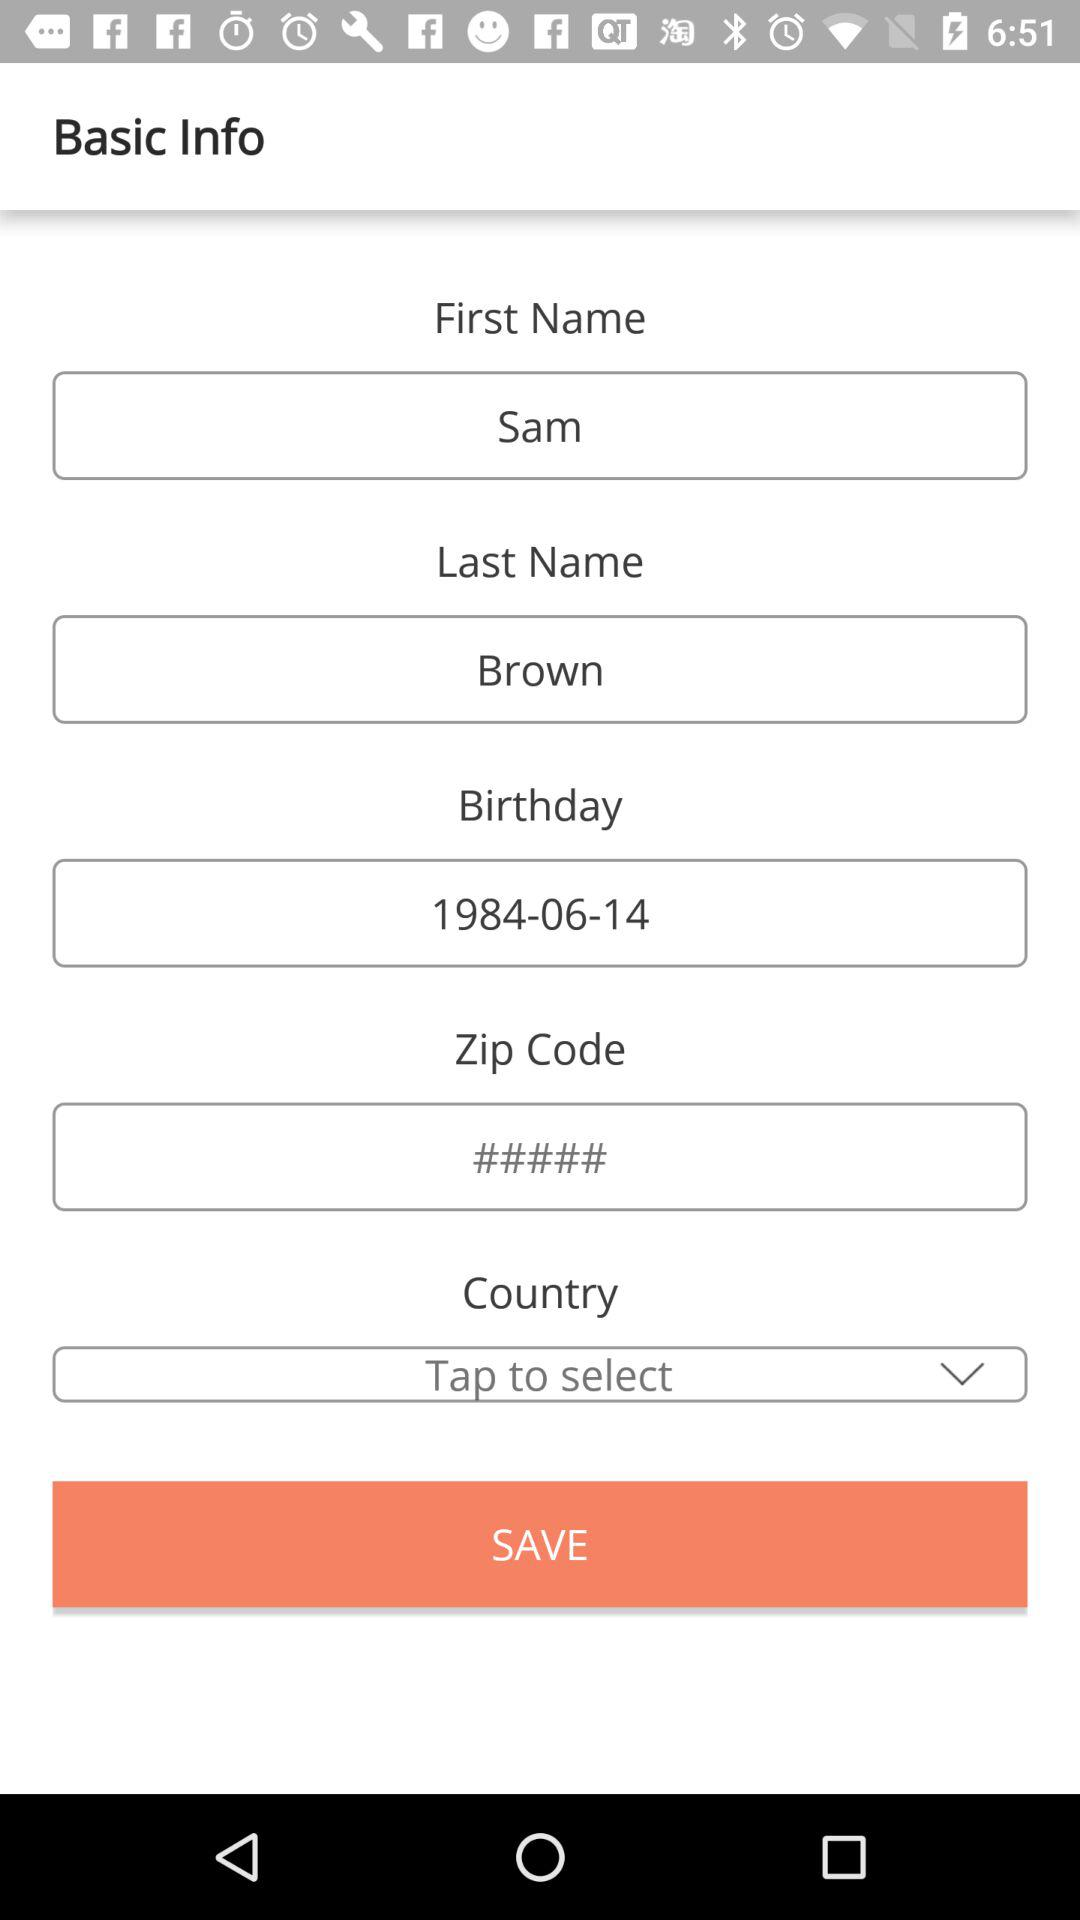What is the last name? The last name is Brown. 